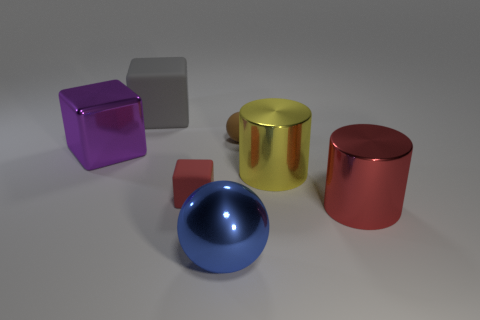There is a cylinder right of the yellow metallic cylinder; does it have the same color as the tiny block?
Keep it short and to the point. Yes. Are the cube in front of the large purple metal thing and the cylinder to the right of the yellow shiny object made of the same material?
Give a very brief answer. No. What material is the big gray cube?
Offer a terse response. Rubber. How many large blue metallic objects are the same shape as the small brown object?
Your response must be concise. 1. What is the material of the cylinder that is the same color as the small block?
Your answer should be very brief. Metal. The ball that is in front of the small matte thing that is on the right side of the ball in front of the tiny brown matte sphere is what color?
Ensure brevity in your answer.  Blue. What number of small objects are brown matte things or blue cylinders?
Offer a very short reply. 1. Are there an equal number of gray matte objects on the right side of the tiny red rubber object and large metallic cylinders?
Ensure brevity in your answer.  No. There is a gray cube; are there any blue metallic balls in front of it?
Keep it short and to the point. Yes. What number of metallic objects are either red cylinders or big purple cylinders?
Your response must be concise. 1. 